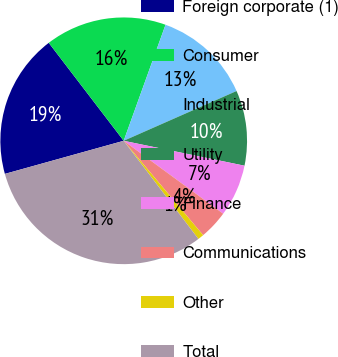<chart> <loc_0><loc_0><loc_500><loc_500><pie_chart><fcel>Foreign corporate (1)<fcel>Consumer<fcel>Industrial<fcel>Utility<fcel>Finance<fcel>Communications<fcel>Other<fcel>Total<nl><fcel>18.93%<fcel>15.9%<fcel>12.88%<fcel>9.85%<fcel>6.83%<fcel>3.8%<fcel>0.78%<fcel>31.03%<nl></chart> 